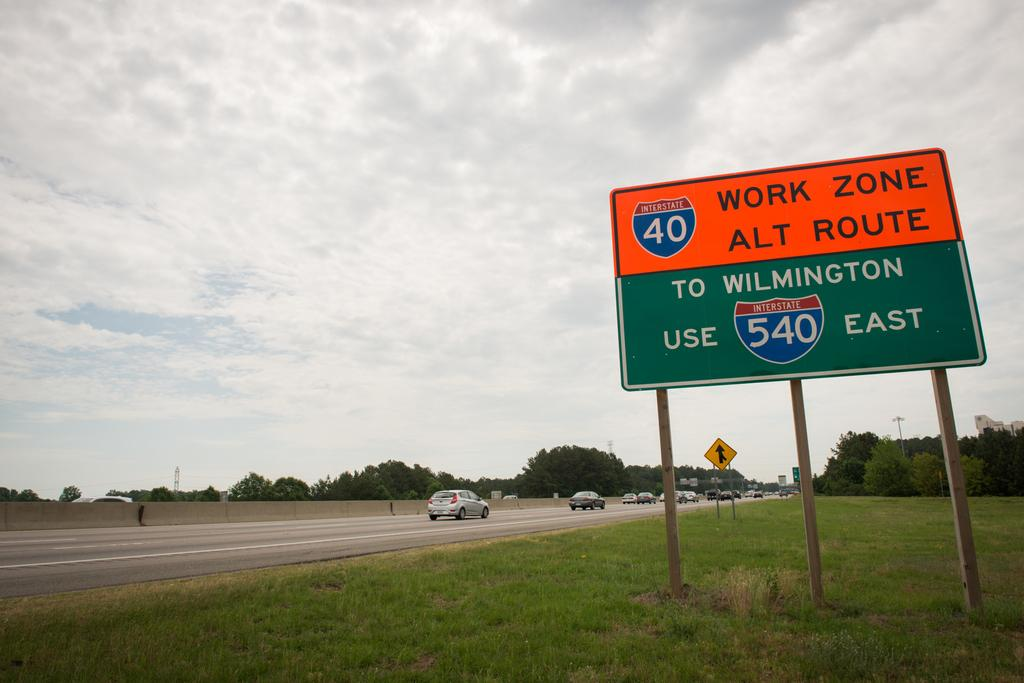Provide a one-sentence caption for the provided image. A road sign along Interstate 40 warning of construction and recommending an alternate route of Wilmington 540 East instead. 